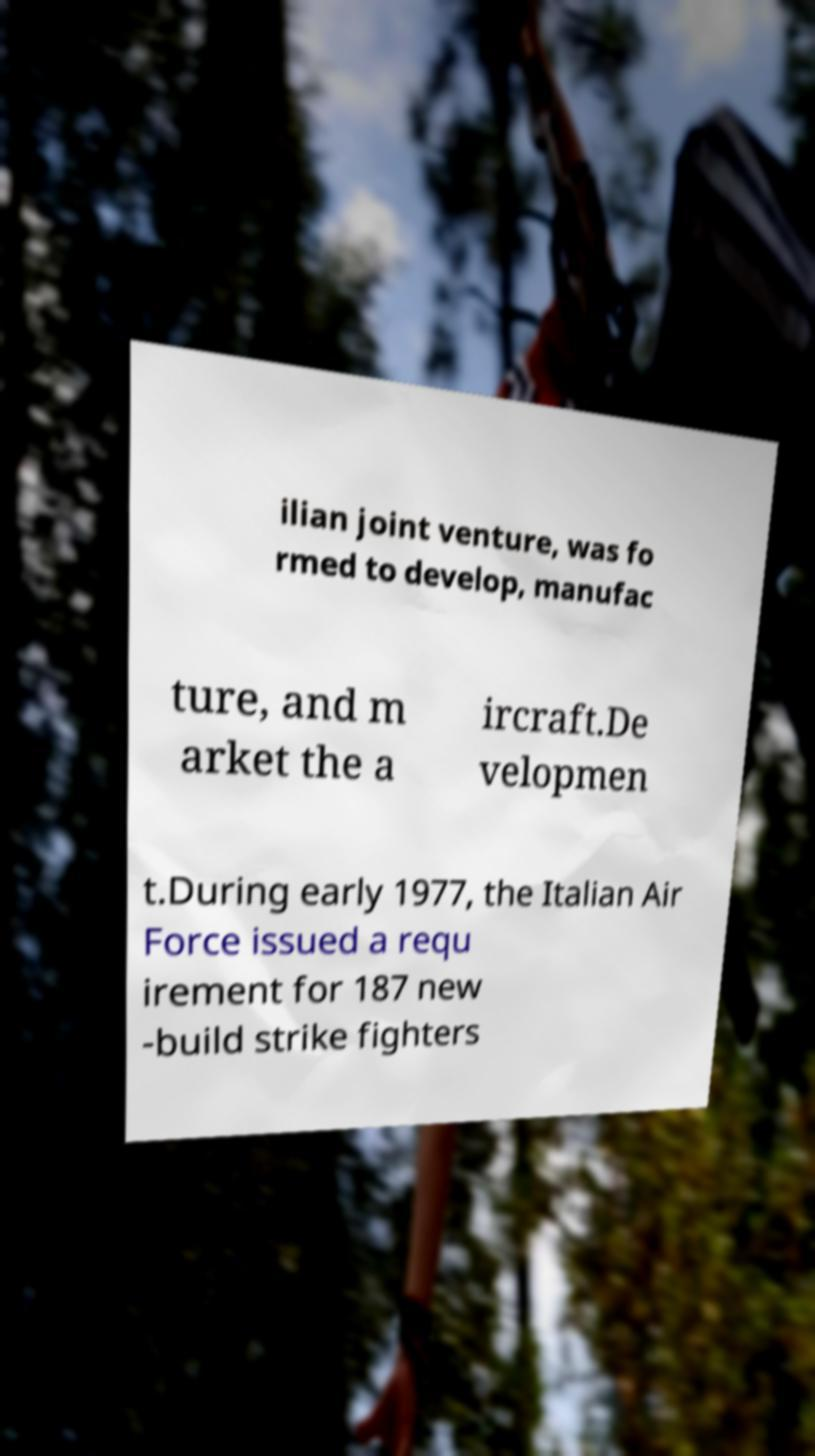For documentation purposes, I need the text within this image transcribed. Could you provide that? ilian joint venture, was fo rmed to develop, manufac ture, and m arket the a ircraft.De velopmen t.During early 1977, the Italian Air Force issued a requ irement for 187 new -build strike fighters 